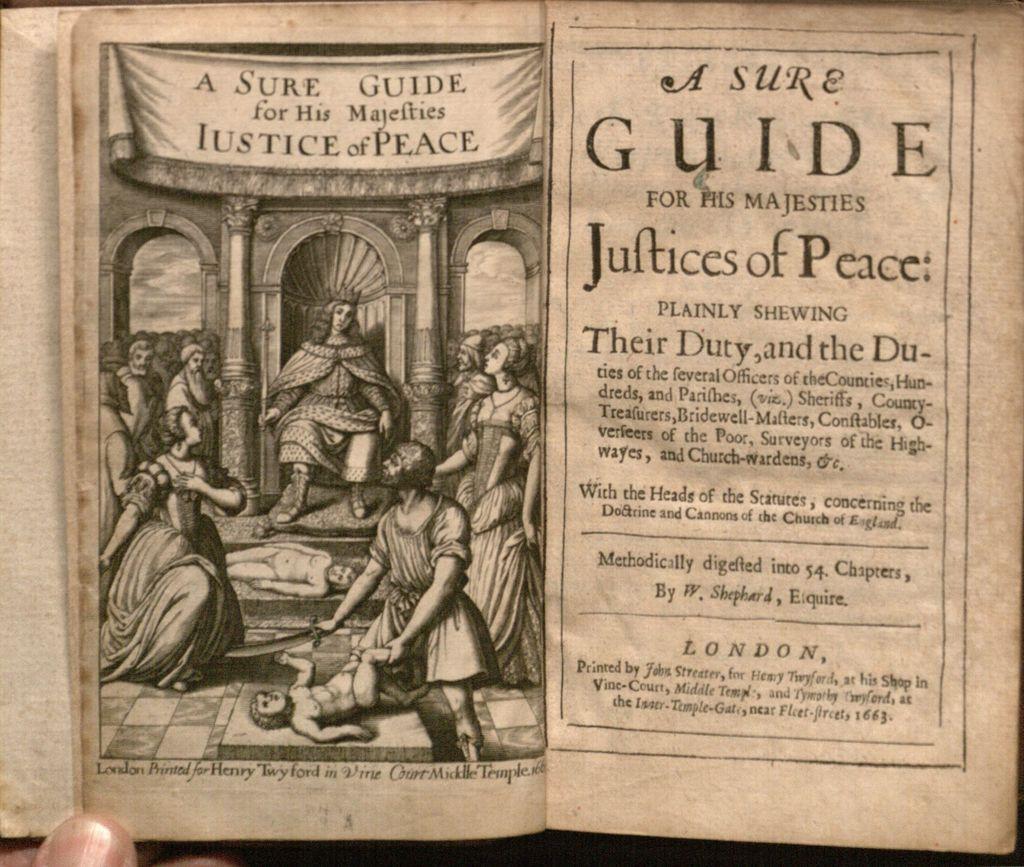What kind of guide is this?
Offer a terse response. A sure guide. 